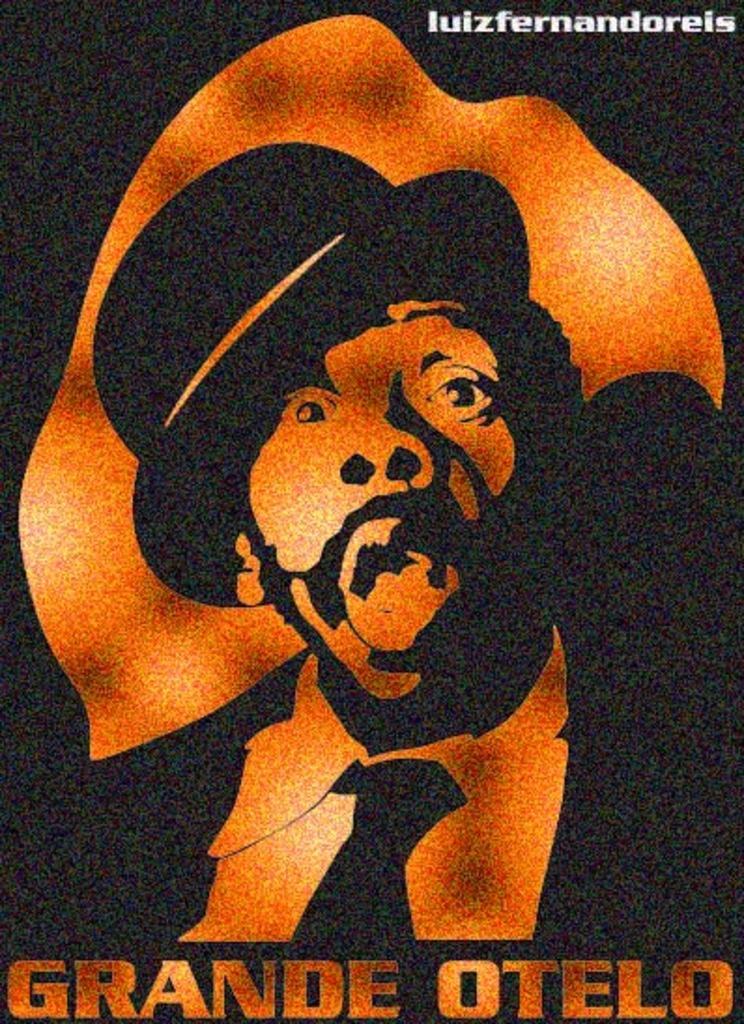What does the text say on the bottom?
Your response must be concise. Grande otelo. 